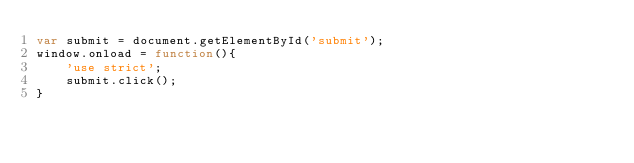Convert code to text. <code><loc_0><loc_0><loc_500><loc_500><_JavaScript_>var submit = document.getElementById('submit');
window.onload = function(){
    'use strict';
    submit.click();
}</code> 